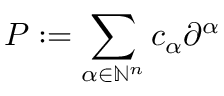Convert formula to latex. <formula><loc_0><loc_0><loc_500><loc_500>P \colon = \sum _ { \alpha \in \mathbb { N } ^ { n } } c _ { \alpha } \partial ^ { \alpha }</formula> 